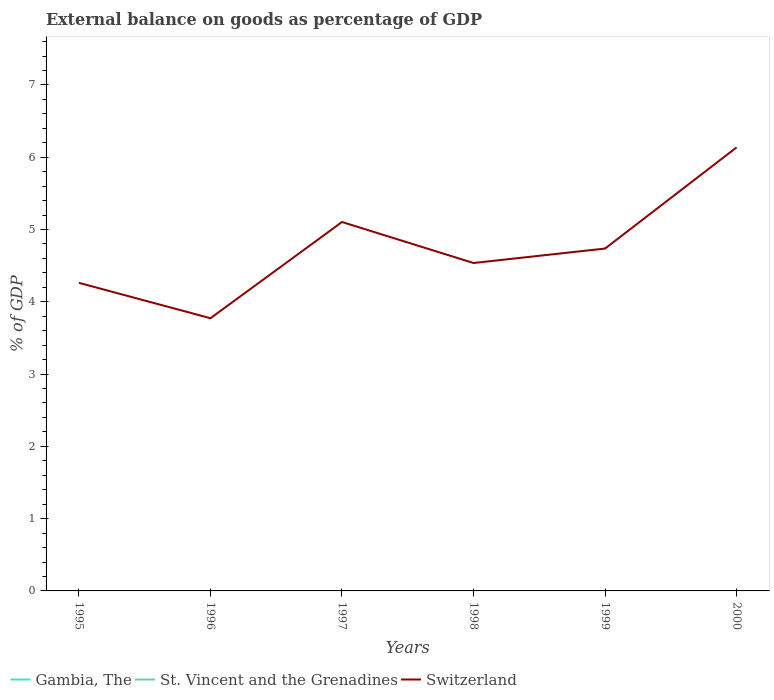How many different coloured lines are there?
Make the answer very short. 1. Does the line corresponding to Gambia, The intersect with the line corresponding to Switzerland?
Your answer should be very brief. No. Across all years, what is the maximum external balance on goods as percentage of GDP in St. Vincent and the Grenadines?
Provide a short and direct response. 0. What is the total external balance on goods as percentage of GDP in Switzerland in the graph?
Make the answer very short. 0.49. What is the difference between the highest and the second highest external balance on goods as percentage of GDP in Switzerland?
Offer a terse response. 2.36. What is the difference between the highest and the lowest external balance on goods as percentage of GDP in Gambia, The?
Offer a very short reply. 0. Is the external balance on goods as percentage of GDP in St. Vincent and the Grenadines strictly greater than the external balance on goods as percentage of GDP in Gambia, The over the years?
Provide a short and direct response. Yes. How many years are there in the graph?
Your answer should be compact. 6. What is the difference between two consecutive major ticks on the Y-axis?
Provide a short and direct response. 1. Does the graph contain grids?
Your response must be concise. No. How are the legend labels stacked?
Your answer should be very brief. Horizontal. What is the title of the graph?
Your answer should be very brief. External balance on goods as percentage of GDP. Does "Slovenia" appear as one of the legend labels in the graph?
Give a very brief answer. No. What is the label or title of the X-axis?
Make the answer very short. Years. What is the label or title of the Y-axis?
Keep it short and to the point. % of GDP. What is the % of GDP in Switzerland in 1995?
Keep it short and to the point. 4.26. What is the % of GDP in Switzerland in 1996?
Offer a very short reply. 3.77. What is the % of GDP in Switzerland in 1997?
Provide a short and direct response. 5.1. What is the % of GDP in Gambia, The in 1998?
Your response must be concise. 0. What is the % of GDP in Switzerland in 1998?
Ensure brevity in your answer.  4.54. What is the % of GDP in Gambia, The in 1999?
Keep it short and to the point. 0. What is the % of GDP of St. Vincent and the Grenadines in 1999?
Keep it short and to the point. 0. What is the % of GDP of Switzerland in 1999?
Your answer should be very brief. 4.74. What is the % of GDP of Gambia, The in 2000?
Offer a terse response. 0. What is the % of GDP of Switzerland in 2000?
Your response must be concise. 6.14. Across all years, what is the maximum % of GDP of Switzerland?
Make the answer very short. 6.14. Across all years, what is the minimum % of GDP in Switzerland?
Give a very brief answer. 3.77. What is the total % of GDP in Gambia, The in the graph?
Your answer should be very brief. 0. What is the total % of GDP in St. Vincent and the Grenadines in the graph?
Make the answer very short. 0. What is the total % of GDP of Switzerland in the graph?
Your answer should be very brief. 28.55. What is the difference between the % of GDP of Switzerland in 1995 and that in 1996?
Your answer should be compact. 0.49. What is the difference between the % of GDP in Switzerland in 1995 and that in 1997?
Provide a succinct answer. -0.84. What is the difference between the % of GDP of Switzerland in 1995 and that in 1998?
Offer a terse response. -0.27. What is the difference between the % of GDP of Switzerland in 1995 and that in 1999?
Your response must be concise. -0.47. What is the difference between the % of GDP in Switzerland in 1995 and that in 2000?
Offer a very short reply. -1.87. What is the difference between the % of GDP in Switzerland in 1996 and that in 1997?
Offer a very short reply. -1.33. What is the difference between the % of GDP of Switzerland in 1996 and that in 1998?
Your answer should be very brief. -0.76. What is the difference between the % of GDP in Switzerland in 1996 and that in 1999?
Make the answer very short. -0.96. What is the difference between the % of GDP in Switzerland in 1996 and that in 2000?
Offer a terse response. -2.36. What is the difference between the % of GDP of Switzerland in 1997 and that in 1998?
Provide a short and direct response. 0.57. What is the difference between the % of GDP of Switzerland in 1997 and that in 1999?
Your answer should be compact. 0.37. What is the difference between the % of GDP in Switzerland in 1997 and that in 2000?
Your answer should be compact. -1.03. What is the difference between the % of GDP in Switzerland in 1998 and that in 2000?
Your answer should be very brief. -1.6. What is the difference between the % of GDP of Switzerland in 1999 and that in 2000?
Your response must be concise. -1.4. What is the average % of GDP of Gambia, The per year?
Offer a terse response. 0. What is the average % of GDP of Switzerland per year?
Provide a short and direct response. 4.76. What is the ratio of the % of GDP of Switzerland in 1995 to that in 1996?
Keep it short and to the point. 1.13. What is the ratio of the % of GDP in Switzerland in 1995 to that in 1997?
Keep it short and to the point. 0.84. What is the ratio of the % of GDP of Switzerland in 1995 to that in 1998?
Give a very brief answer. 0.94. What is the ratio of the % of GDP in Switzerland in 1995 to that in 1999?
Your answer should be compact. 0.9. What is the ratio of the % of GDP of Switzerland in 1995 to that in 2000?
Your response must be concise. 0.69. What is the ratio of the % of GDP of Switzerland in 1996 to that in 1997?
Offer a terse response. 0.74. What is the ratio of the % of GDP in Switzerland in 1996 to that in 1998?
Give a very brief answer. 0.83. What is the ratio of the % of GDP in Switzerland in 1996 to that in 1999?
Your answer should be very brief. 0.8. What is the ratio of the % of GDP in Switzerland in 1996 to that in 2000?
Keep it short and to the point. 0.61. What is the ratio of the % of GDP in Switzerland in 1997 to that in 1998?
Ensure brevity in your answer.  1.13. What is the ratio of the % of GDP of Switzerland in 1997 to that in 1999?
Your answer should be compact. 1.08. What is the ratio of the % of GDP in Switzerland in 1997 to that in 2000?
Provide a succinct answer. 0.83. What is the ratio of the % of GDP of Switzerland in 1998 to that in 1999?
Ensure brevity in your answer.  0.96. What is the ratio of the % of GDP of Switzerland in 1998 to that in 2000?
Give a very brief answer. 0.74. What is the ratio of the % of GDP of Switzerland in 1999 to that in 2000?
Your answer should be very brief. 0.77. What is the difference between the highest and the second highest % of GDP of Switzerland?
Keep it short and to the point. 1.03. What is the difference between the highest and the lowest % of GDP of Switzerland?
Give a very brief answer. 2.36. 